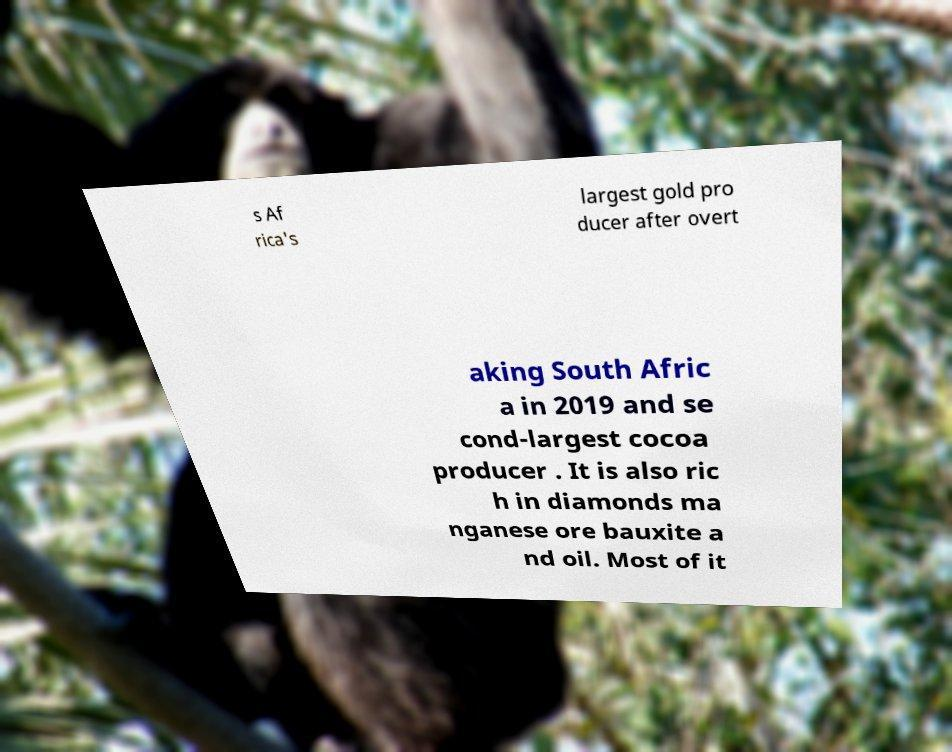Can you accurately transcribe the text from the provided image for me? s Af rica's largest gold pro ducer after overt aking South Afric a in 2019 and se cond-largest cocoa producer . It is also ric h in diamonds ma nganese ore bauxite a nd oil. Most of it 